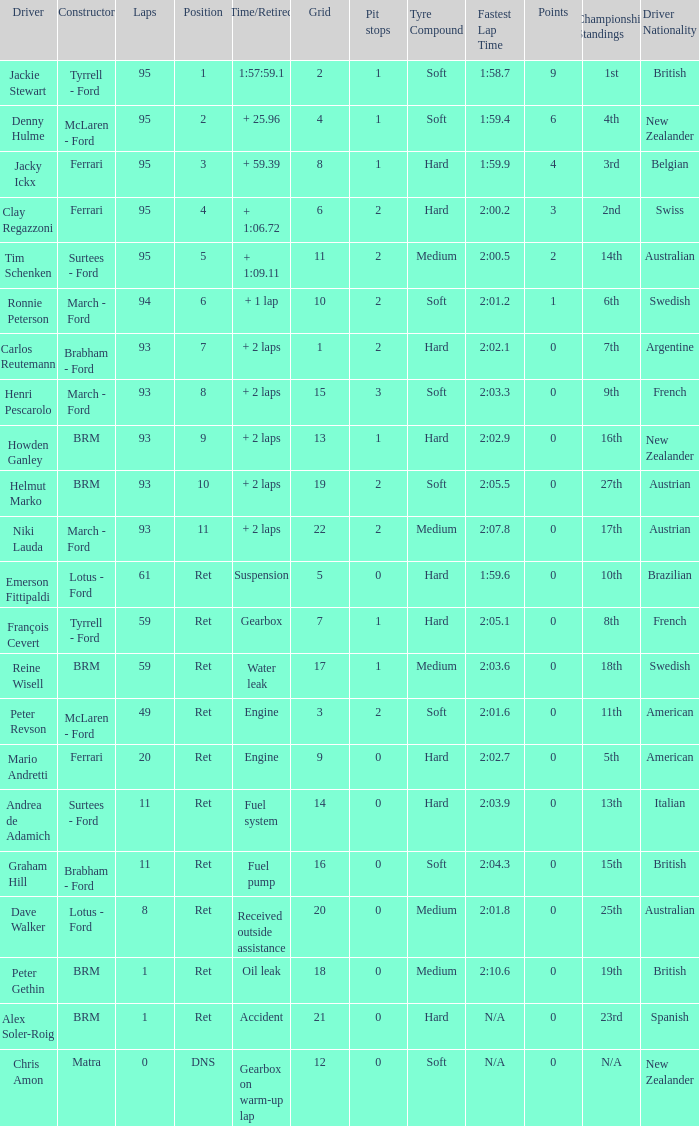What is the largest number of laps with a Grid larger than 14, a Time/Retired of + 2 laps, and a Driver of helmut marko? 93.0. 